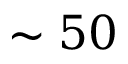Convert formula to latex. <formula><loc_0><loc_0><loc_500><loc_500>\sim 5 0</formula> 